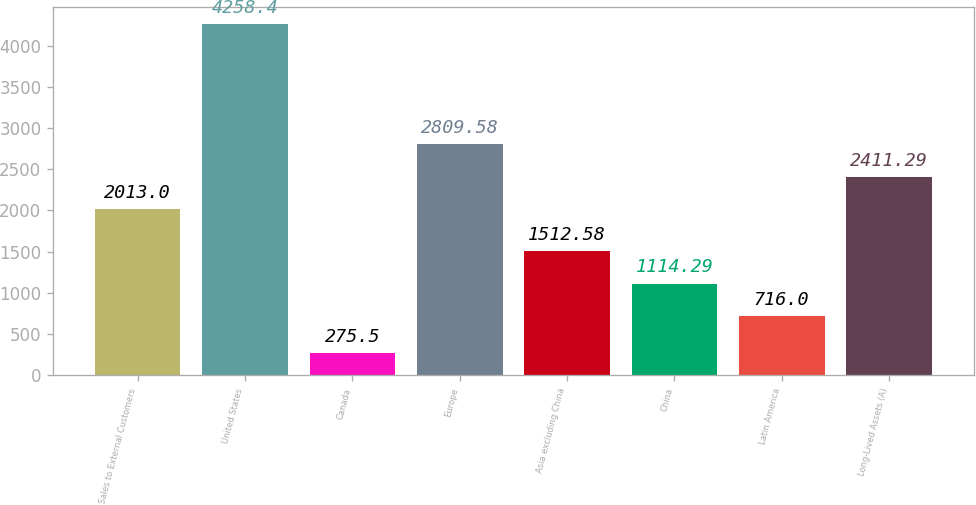Convert chart. <chart><loc_0><loc_0><loc_500><loc_500><bar_chart><fcel>Sales to External Customers<fcel>United States<fcel>Canada<fcel>Europe<fcel>Asia excluding China<fcel>China<fcel>Latin America<fcel>Long-Lived Assets (A)<nl><fcel>2013<fcel>4258.4<fcel>275.5<fcel>2809.58<fcel>1512.58<fcel>1114.29<fcel>716<fcel>2411.29<nl></chart> 